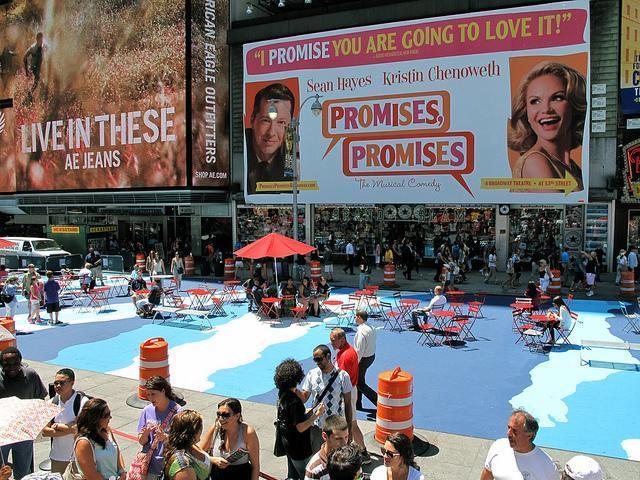How many people are there?
Give a very brief answer. 9. 